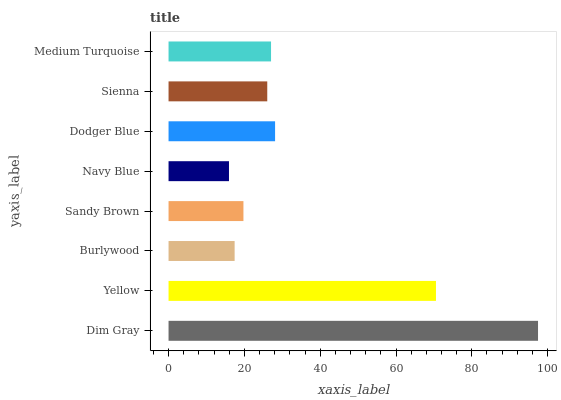Is Navy Blue the minimum?
Answer yes or no. Yes. Is Dim Gray the maximum?
Answer yes or no. Yes. Is Yellow the minimum?
Answer yes or no. No. Is Yellow the maximum?
Answer yes or no. No. Is Dim Gray greater than Yellow?
Answer yes or no. Yes. Is Yellow less than Dim Gray?
Answer yes or no. Yes. Is Yellow greater than Dim Gray?
Answer yes or no. No. Is Dim Gray less than Yellow?
Answer yes or no. No. Is Medium Turquoise the high median?
Answer yes or no. Yes. Is Sienna the low median?
Answer yes or no. Yes. Is Yellow the high median?
Answer yes or no. No. Is Dodger Blue the low median?
Answer yes or no. No. 